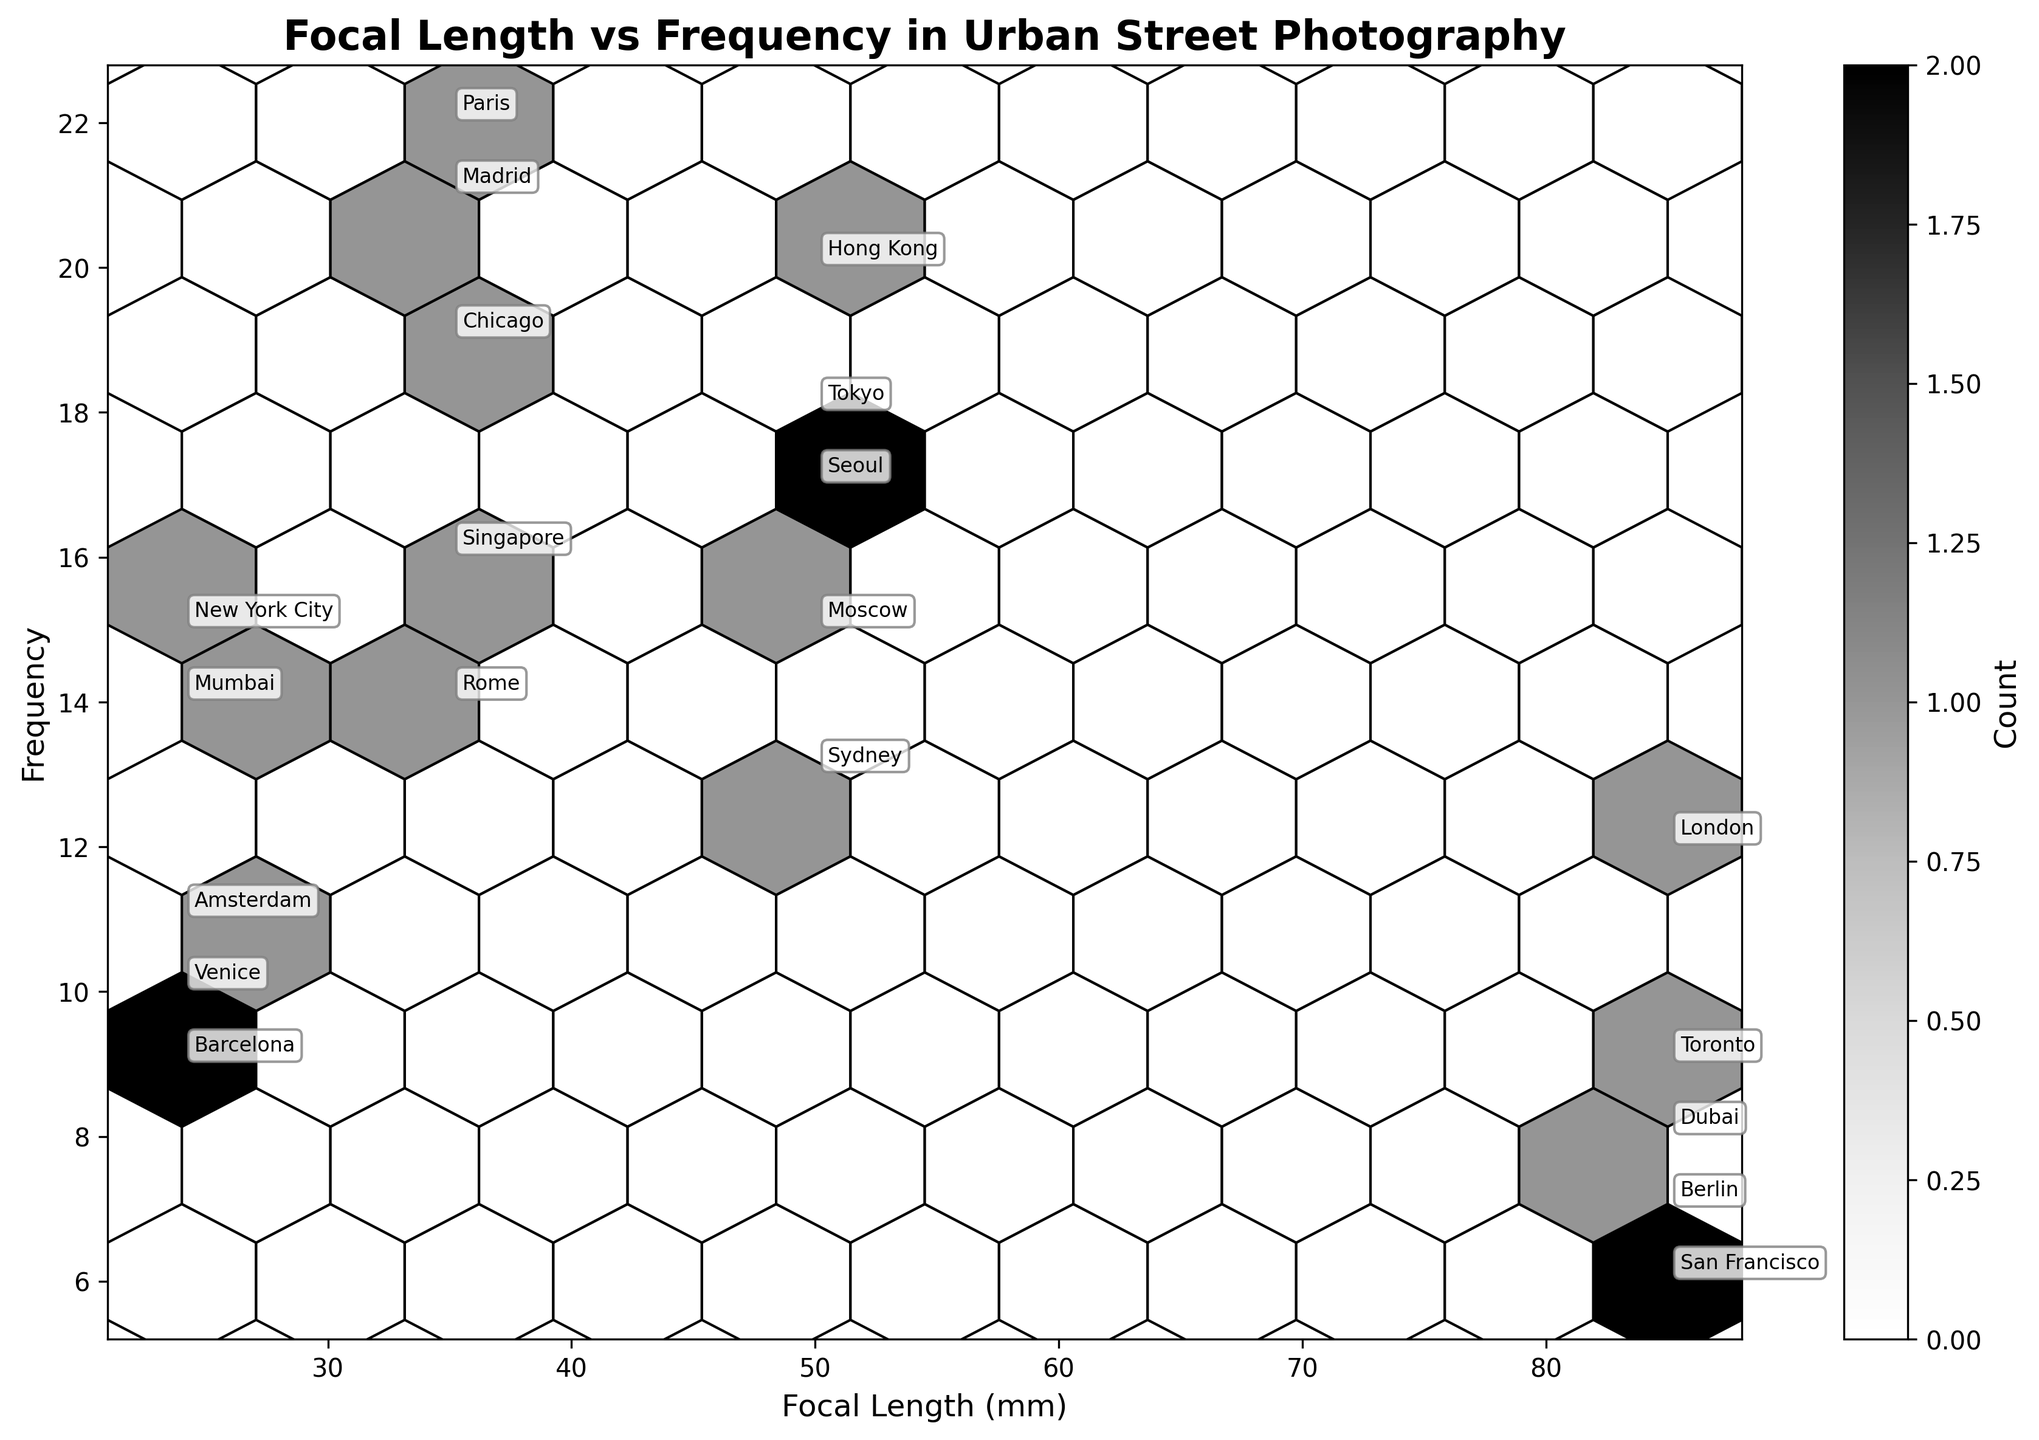How many different focal length values are present in the figure? You can identify the distinct focal length values by looking at the x-axis and the annotated labels. The focal length values are 24, 35, 50, and 85 mm.
Answer: 4 Which urban setting has the highest frequency for a focal length of 35mm? Look for focal length 35mm along the x-axis and find the highest point in terms of frequency on the y-axis within the 35mm column. The highest frequency for 35mm is 22, annotated with "Paris."
Answer: Paris What is the sum of frequencies for focal length values of 24mm and 50mm? Identify the frequency values associated with focal lengths 24mm and 50mm: for 24mm, the frequencies are 15, 9, 11, 10, and 14; for 50mm, the frequencies are 18, 20, 13, 17, and 15. Sum these values: \( 15+9+11+10+14+18+20+13+17+15 = 142 \).
Answer: 142 Which focal length value has a higher median frequency, 35mm or 85mm? Calculate the median frequency for each focal length. For 35mm: 14, 16, 19, 21, 22 (median is 19). For 85mm: 7, 8, 9, 12, 6 (median is 8). Compare the two medians.
Answer: 35mm Between focal lengths of 24mm and 50mm, which has a wider range of frequencies? Determine the range of frequencies for both focal lengths by subtracting the lowest frequency from the highest frequency. For 24mm: \( 15-9=6 \). For 50mm: \( 20-13=7 \). Compare the ranges.
Answer: 50mm Which urban setting corresponds to the highest frequency in the plot? Search for the highest frequency value on the y-axis and find the corresponding annotated urban setting. The highest frequency is 22, annotated with "Paris."
Answer: Paris What is the average frequency value of all focal lengths combined? Sum the frequency values for all entries: \( 15+22+18+12+9+14+20+7+11+16+13+8+10+19+17+6+14+21+15+9=266 \) and divide by the number of data points (20): \( 266 / 20 = 13.3 \).
Answer: 13.3 Which focal length has the least variation in frequency? Compare the range (difference between maximum and minimum) of frequencies for all focal lengths. 24mm: \( 15-9=6 \), 35mm: \( 22-14=8 \), 50mm: \( 20-13=7 \), 85mm: \( 12-6=6 \). Both 24mm and 85mm have the least variation of 6.
Answer: 24mm and 85mm What is the frequency of the urban setting labeled "Seoul"? Locate the annotation "Seoul" on the plot to determine its frequency value. "Seoul" is associated with a frequency of 17.
Answer: 17 Which urban setting among "New York City," "Tokyo," and "London" has the lowest frequency? Find the frequencies related to "New York City" (15), "Tokyo" (18), and "London" (12) by locating their annotations on the plot and comparing the values.
Answer: London 